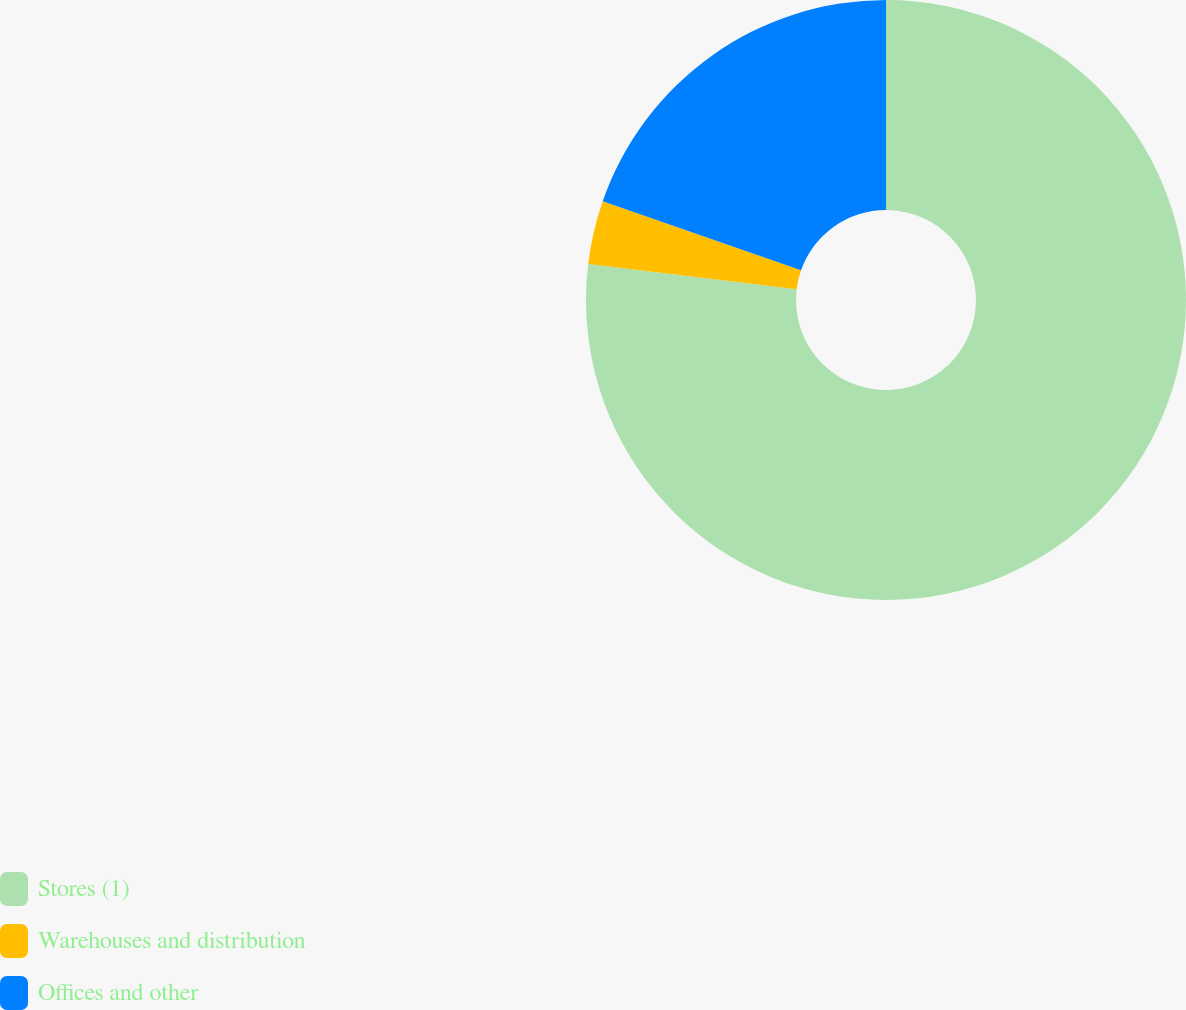Convert chart to OTSL. <chart><loc_0><loc_0><loc_500><loc_500><pie_chart><fcel>Stores (1)<fcel>Warehouses and distribution<fcel>Offices and other<nl><fcel>76.92%<fcel>3.42%<fcel>19.66%<nl></chart> 